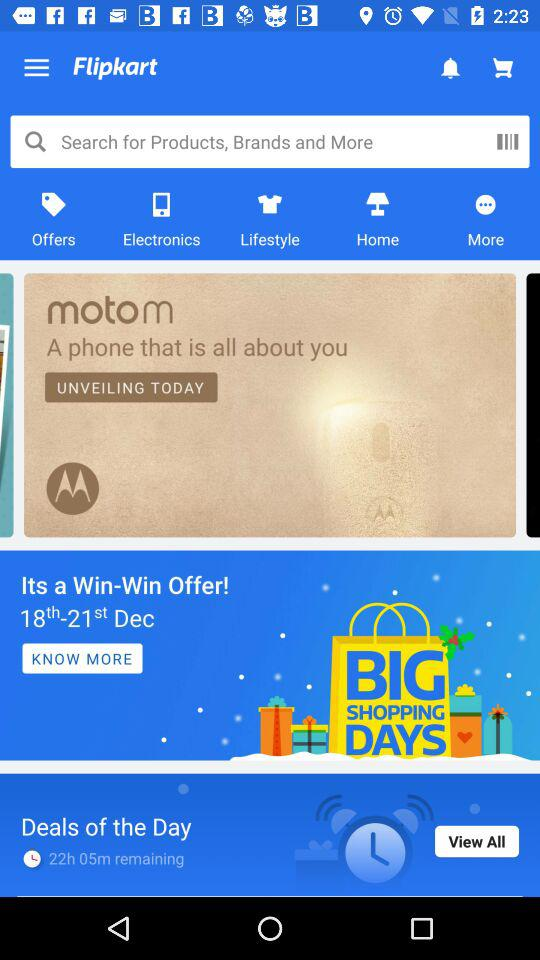How many more deals are there than offers?
Answer the question using a single word or phrase. 1 